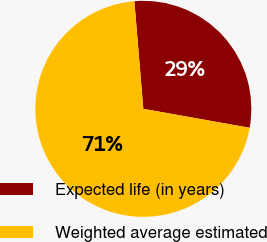Convert chart to OTSL. <chart><loc_0><loc_0><loc_500><loc_500><pie_chart><fcel>Expected life (in years)<fcel>Weighted average estimated<nl><fcel>29.13%<fcel>70.87%<nl></chart> 